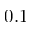Convert formula to latex. <formula><loc_0><loc_0><loc_500><loc_500>0 . 1</formula> 